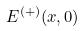Convert formula to latex. <formula><loc_0><loc_0><loc_500><loc_500>E ^ { ( + ) } ( x , 0 )</formula> 